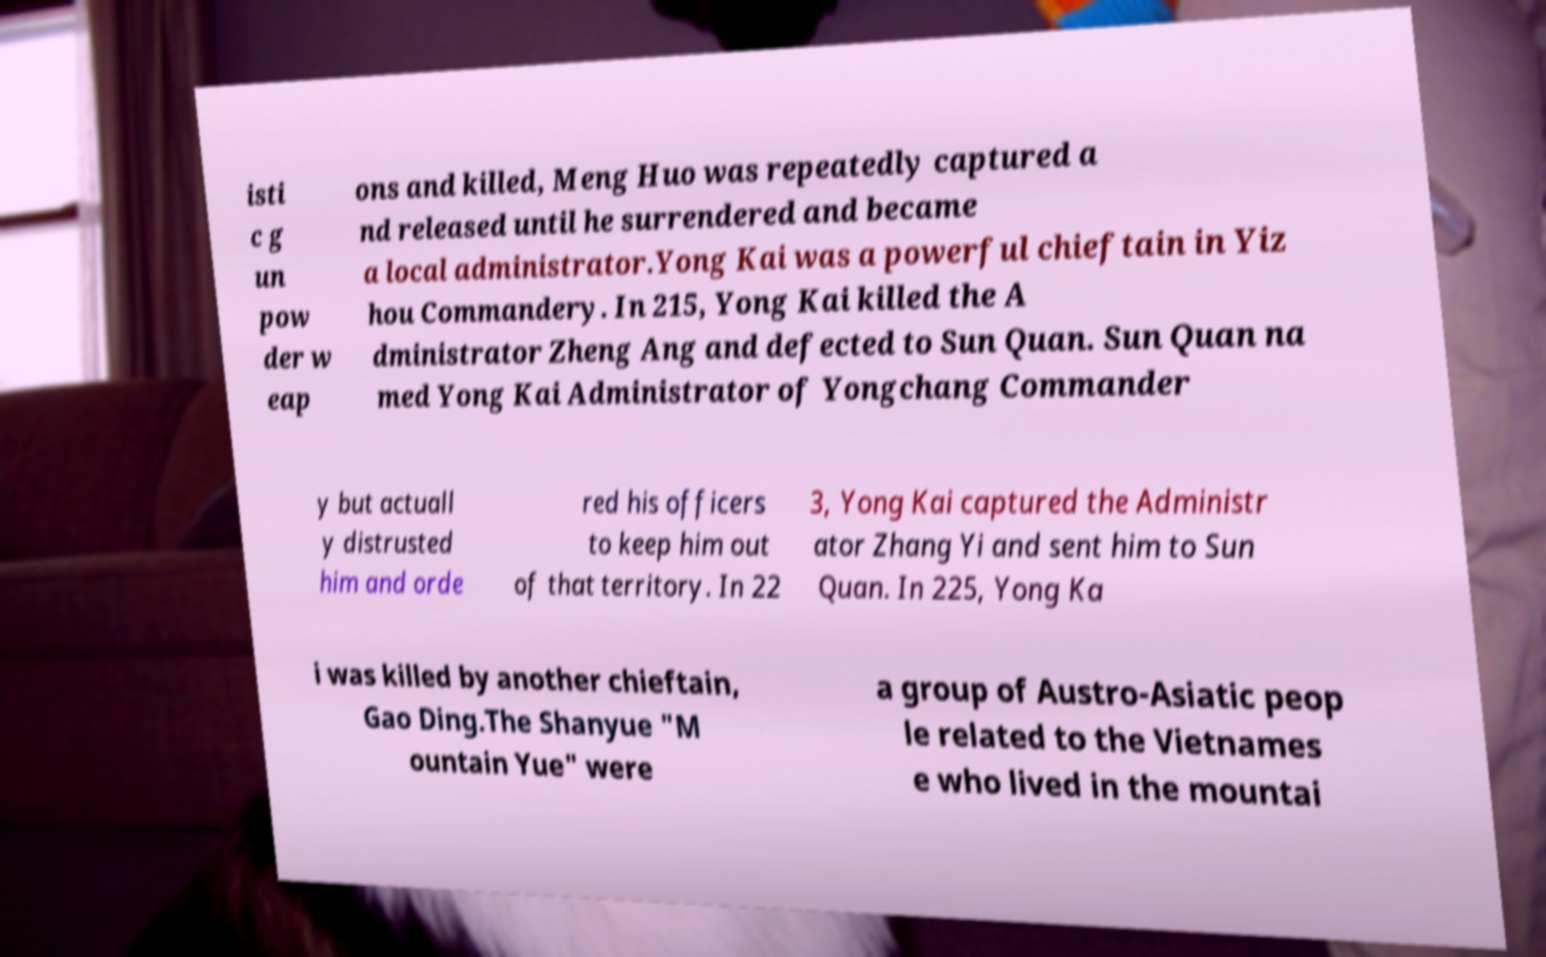Please read and relay the text visible in this image. What does it say? isti c g un pow der w eap ons and killed, Meng Huo was repeatedly captured a nd released until he surrendered and became a local administrator.Yong Kai was a powerful chieftain in Yiz hou Commandery. In 215, Yong Kai killed the A dministrator Zheng Ang and defected to Sun Quan. Sun Quan na med Yong Kai Administrator of Yongchang Commander y but actuall y distrusted him and orde red his officers to keep him out of that territory. In 22 3, Yong Kai captured the Administr ator Zhang Yi and sent him to Sun Quan. In 225, Yong Ka i was killed by another chieftain, Gao Ding.The Shanyue "M ountain Yue" were a group of Austro-Asiatic peop le related to the Vietnames e who lived in the mountai 